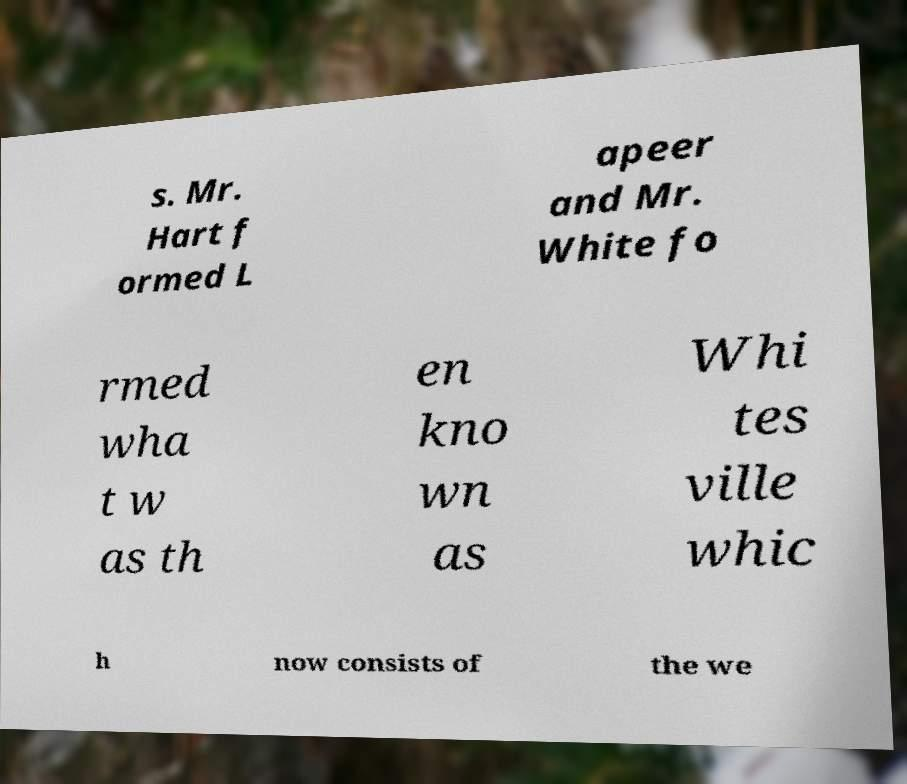Please identify and transcribe the text found in this image. s. Mr. Hart f ormed L apeer and Mr. White fo rmed wha t w as th en kno wn as Whi tes ville whic h now consists of the we 